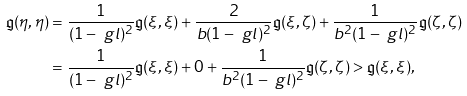Convert formula to latex. <formula><loc_0><loc_0><loc_500><loc_500>\mathfrak g ( \eta , \eta ) & = \frac { 1 } { ( 1 - \ g l ) ^ { 2 } } \mathfrak g ( \xi , \xi ) + \frac { 2 } { b ( 1 - \ g l ) ^ { 2 } } \mathfrak g ( \xi , \zeta ) + \frac { 1 } { b ^ { 2 } ( 1 - \ g l ) ^ { 2 } } \mathfrak g ( \zeta , \zeta ) \\ & = \frac { 1 } { ( 1 - \ g l ) ^ { 2 } } \mathfrak g ( \xi , \xi ) + 0 + \frac { 1 } { b ^ { 2 } ( 1 - \ g l ) ^ { 2 } } \mathfrak g ( \zeta , \zeta ) > \mathfrak g ( \xi , \xi ) ,</formula> 